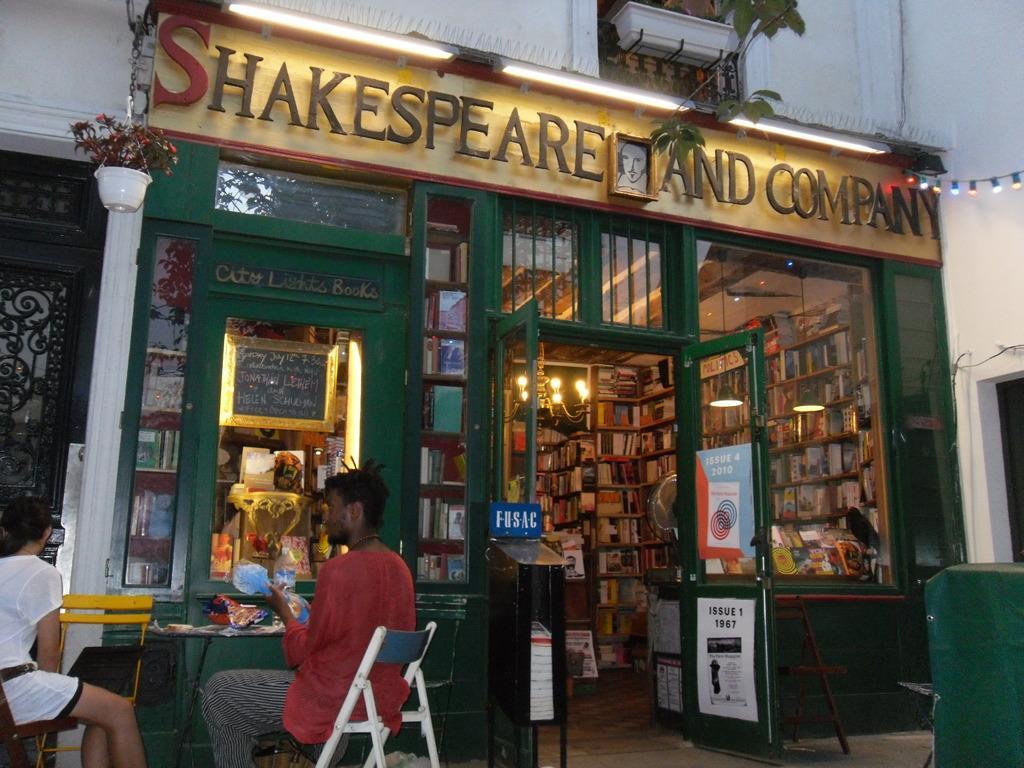Could you give a brief overview of what you see in this image? This is the picture taken in the outdoor, there are two persons sitting on chairs in front of the people there is a table on the table on the table there are so items. There is a shop, in the shop there are shelves in shelfs there are lot of books, glass windows. To the door there are some posters. Top of the shop there are some plants. 